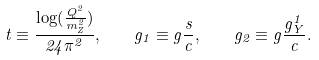<formula> <loc_0><loc_0><loc_500><loc_500>t \equiv \frac { \log ( \frac { Q ^ { 2 } } { m _ { Z } ^ { 2 } } ) } { 2 4 \pi ^ { 2 } } , \quad g _ { 1 } \equiv g \frac { s } { c } , \quad g _ { 2 } \equiv g \frac { g _ { Y } ^ { 1 } } { c } .</formula> 